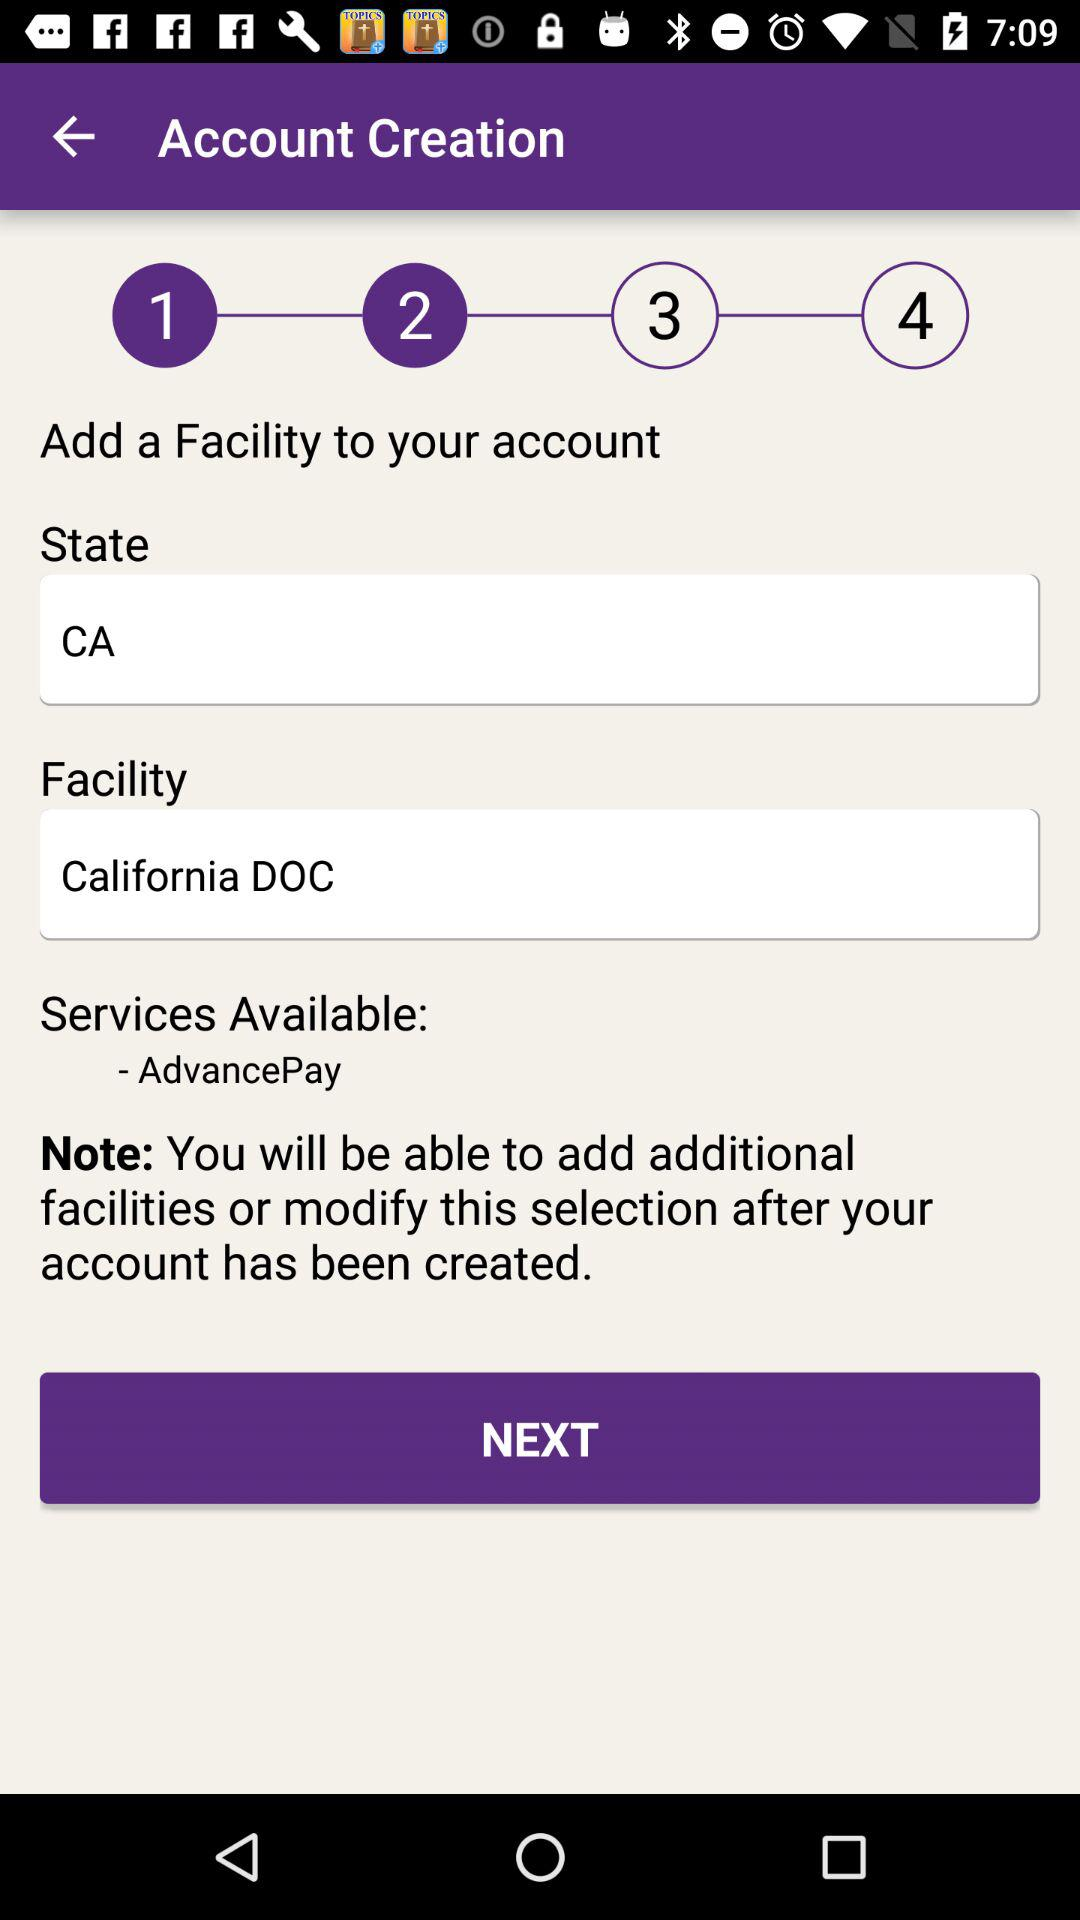What state is mentioned? The mentioned state is CA. 